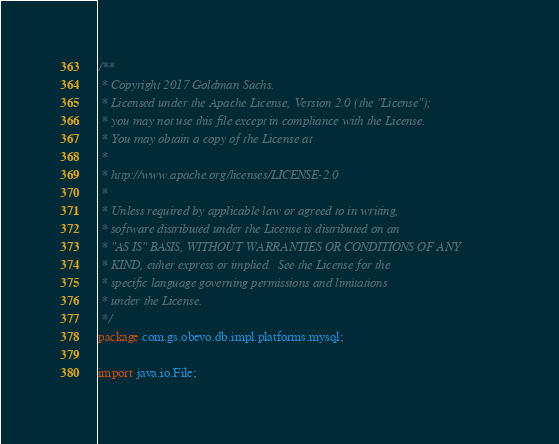Convert code to text. <code><loc_0><loc_0><loc_500><loc_500><_Java_>/**
 * Copyright 2017 Goldman Sachs.
 * Licensed under the Apache License, Version 2.0 (the "License");
 * you may not use this file except in compliance with the License.
 * You may obtain a copy of the License at
 *
 * http://www.apache.org/licenses/LICENSE-2.0
 *
 * Unless required by applicable law or agreed to in writing,
 * software distributed under the License is distributed on an
 * "AS IS" BASIS, WITHOUT WARRANTIES OR CONDITIONS OF ANY
 * KIND, either express or implied.  See the License for the
 * specific language governing permissions and limitations
 * under the License.
 */
package com.gs.obevo.db.impl.platforms.mysql;

import java.io.File;
</code> 